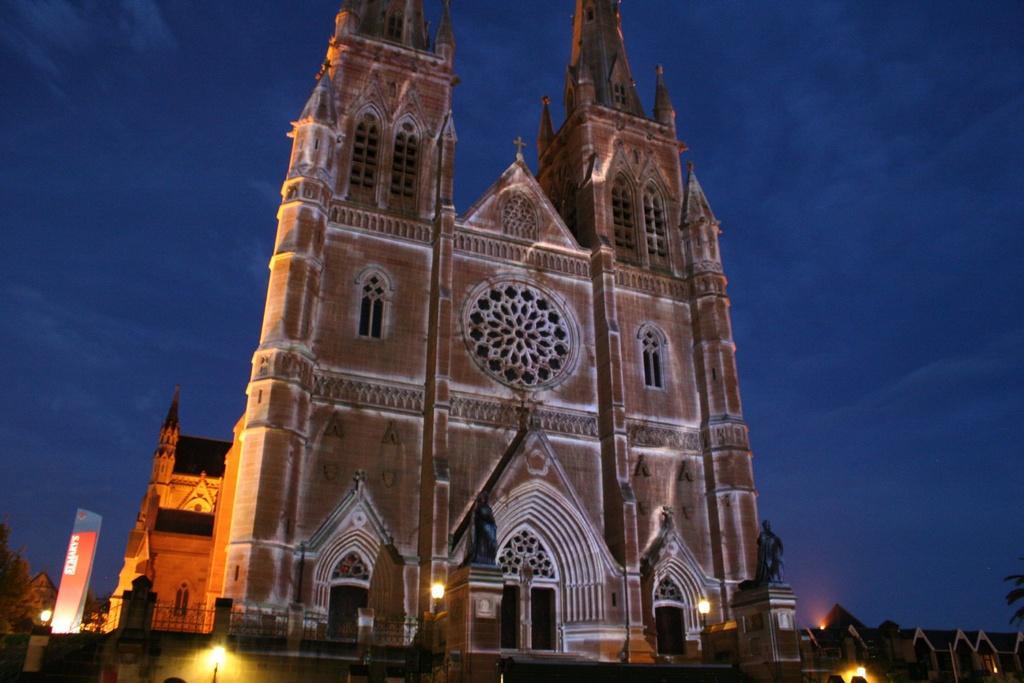Can you describe this image briefly? In front of the picture, we see a building and it looks like a church. At the bottom, we see the light poles and the railing. Behind that, we see the building. On the left side, we see the trees, light pole and a board in white and blue color with some text written on it. In the background, we see the sky, which is blue in color. This picture might be clicked in the dark. 